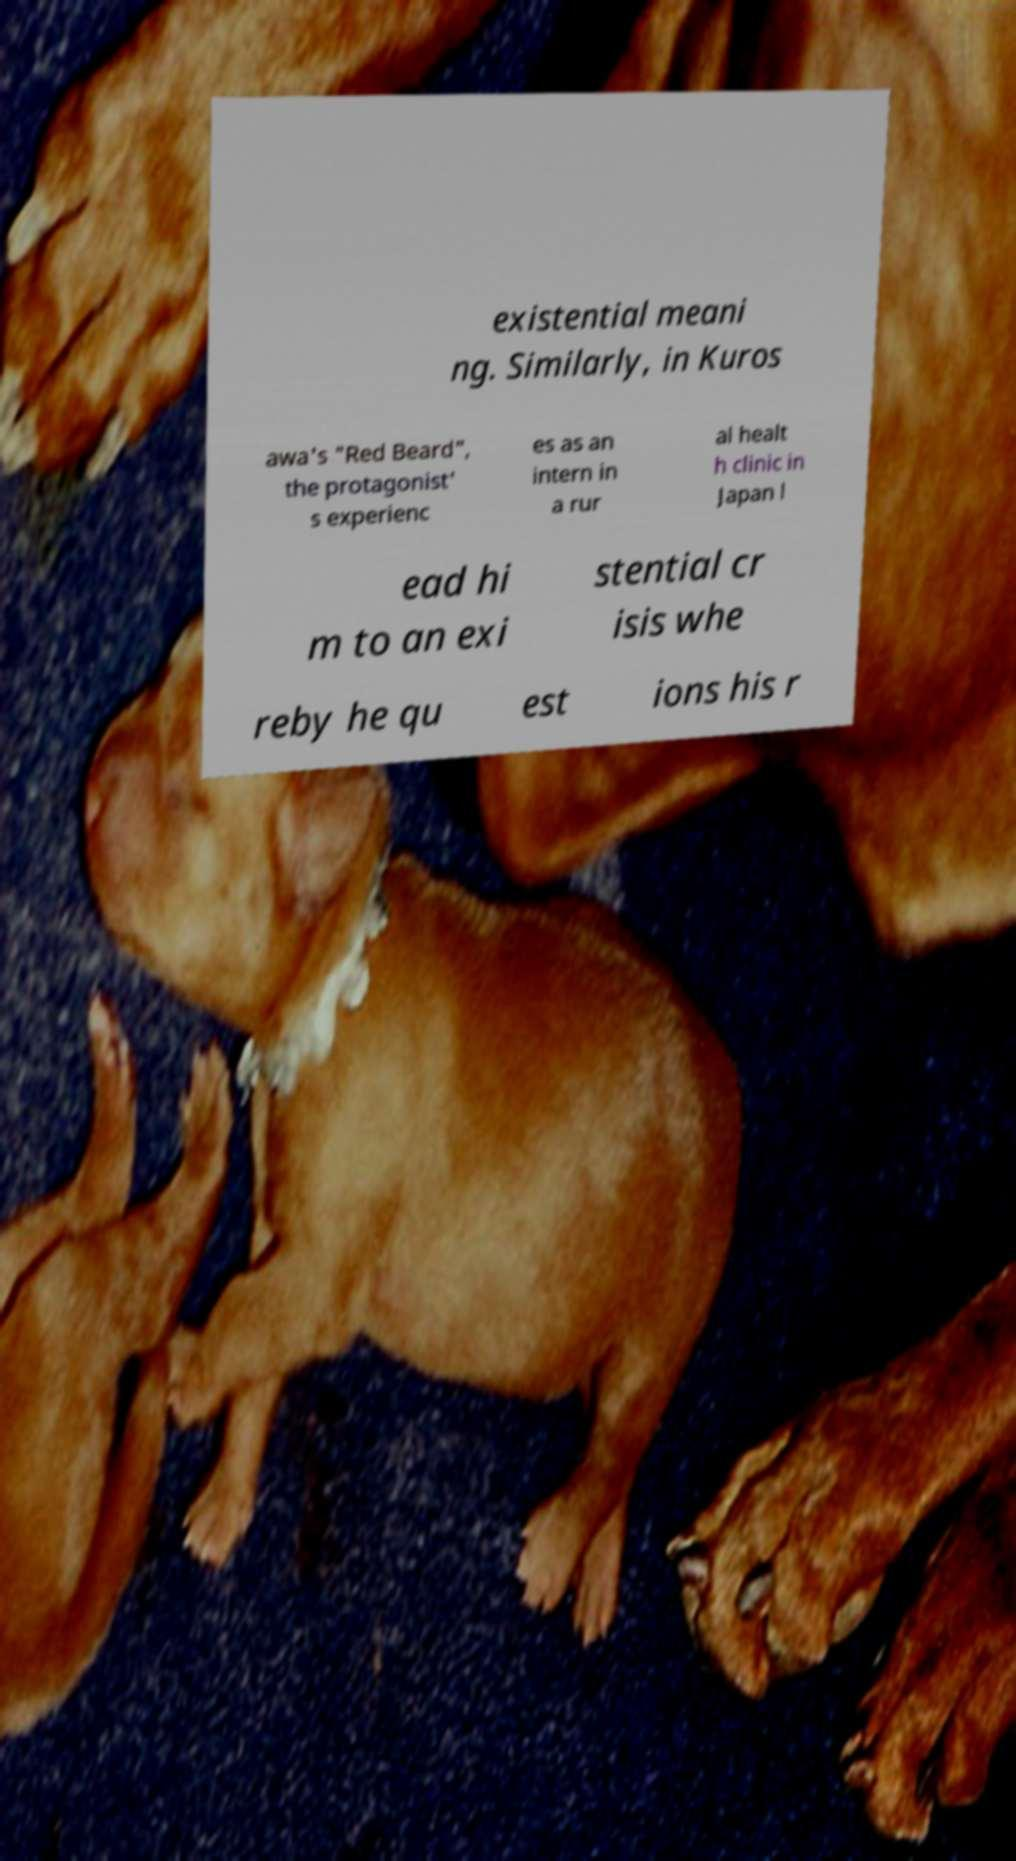There's text embedded in this image that I need extracted. Can you transcribe it verbatim? existential meani ng. Similarly, in Kuros awa's "Red Beard", the protagonist' s experienc es as an intern in a rur al healt h clinic in Japan l ead hi m to an exi stential cr isis whe reby he qu est ions his r 